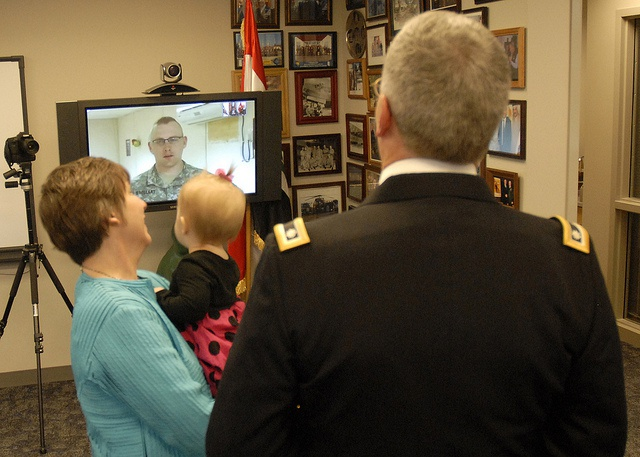Describe the objects in this image and their specific colors. I can see people in olive, black, gray, and maroon tones, people in olive, teal, and turquoise tones, tv in olive, ivory, black, darkgray, and beige tones, people in olive, black, tan, and maroon tones, and people in olive, darkgray, tan, and gray tones in this image. 